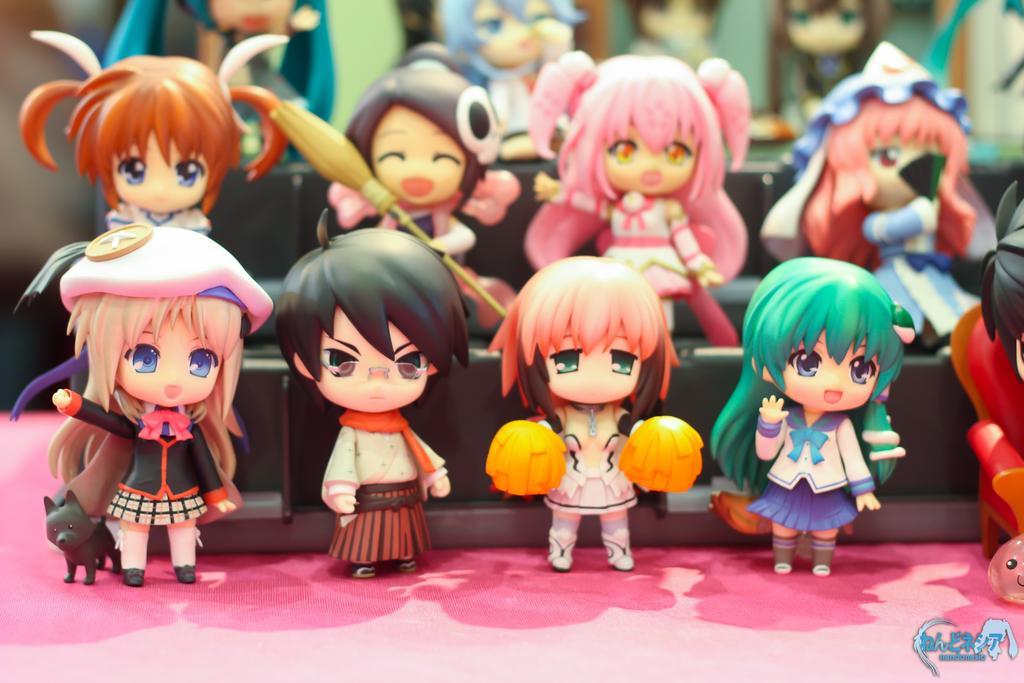Please provide a concise description of this image. In this picture, we see the toy dolls or the figurines. At the bottom, it might be a table which is covered with the pink color cloth. This picture is blurred in the background. 